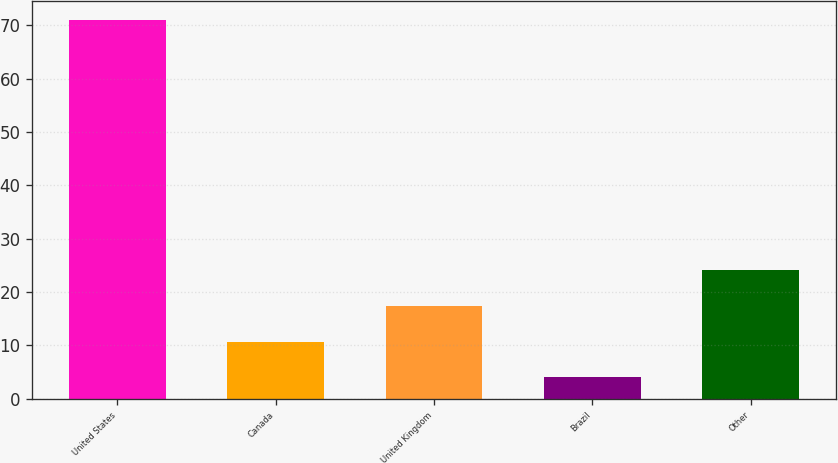Convert chart to OTSL. <chart><loc_0><loc_0><loc_500><loc_500><bar_chart><fcel>United States<fcel>Canada<fcel>United Kingdom<fcel>Brazil<fcel>Other<nl><fcel>71<fcel>10.7<fcel>17.4<fcel>4<fcel>24.1<nl></chart> 